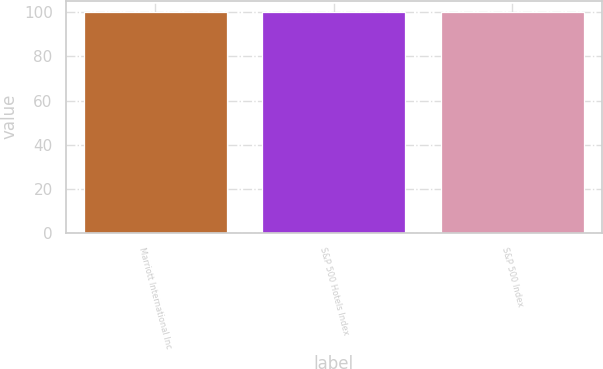Convert chart. <chart><loc_0><loc_0><loc_500><loc_500><bar_chart><fcel>Marriott International Inc<fcel>S&P 500 Hotels Index<fcel>S&P 500 Index<nl><fcel>100<fcel>100.1<fcel>100.2<nl></chart> 